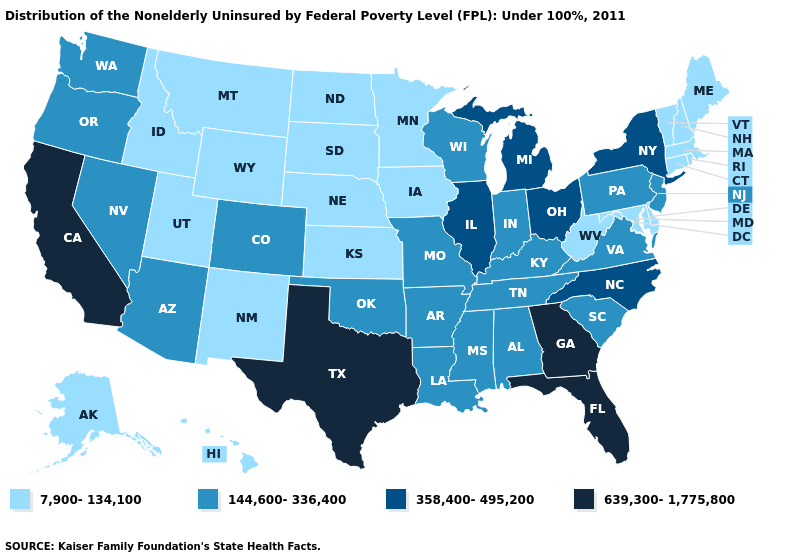Name the states that have a value in the range 7,900-134,100?
Quick response, please. Alaska, Connecticut, Delaware, Hawaii, Idaho, Iowa, Kansas, Maine, Maryland, Massachusetts, Minnesota, Montana, Nebraska, New Hampshire, New Mexico, North Dakota, Rhode Island, South Dakota, Utah, Vermont, West Virginia, Wyoming. Does the first symbol in the legend represent the smallest category?
Short answer required. Yes. Among the states that border North Dakota , which have the lowest value?
Short answer required. Minnesota, Montana, South Dakota. What is the value of Arkansas?
Answer briefly. 144,600-336,400. What is the value of Illinois?
Give a very brief answer. 358,400-495,200. How many symbols are there in the legend?
Quick response, please. 4. What is the value of Illinois?
Write a very short answer. 358,400-495,200. What is the lowest value in the USA?
Answer briefly. 7,900-134,100. Does the map have missing data?
Be succinct. No. Among the states that border Utah , which have the highest value?
Write a very short answer. Arizona, Colorado, Nevada. Among the states that border Massachusetts , does Vermont have the lowest value?
Quick response, please. Yes. What is the value of North Dakota?
Keep it brief. 7,900-134,100. What is the value of Idaho?
Keep it brief. 7,900-134,100. What is the value of Hawaii?
Short answer required. 7,900-134,100. What is the value of Tennessee?
Concise answer only. 144,600-336,400. 